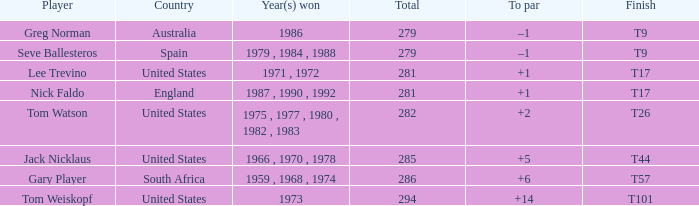Who has the highest total and a to par of +14? 294.0. 